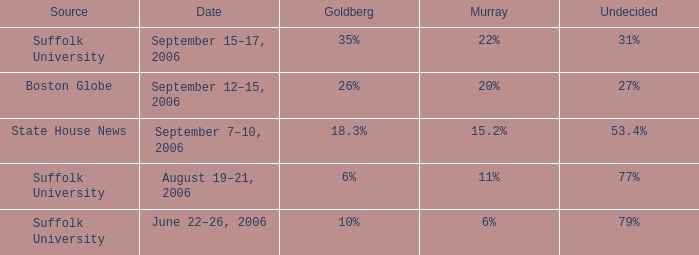What is the date of the poll with Goldberg at 26%? September 12–15, 2006. 